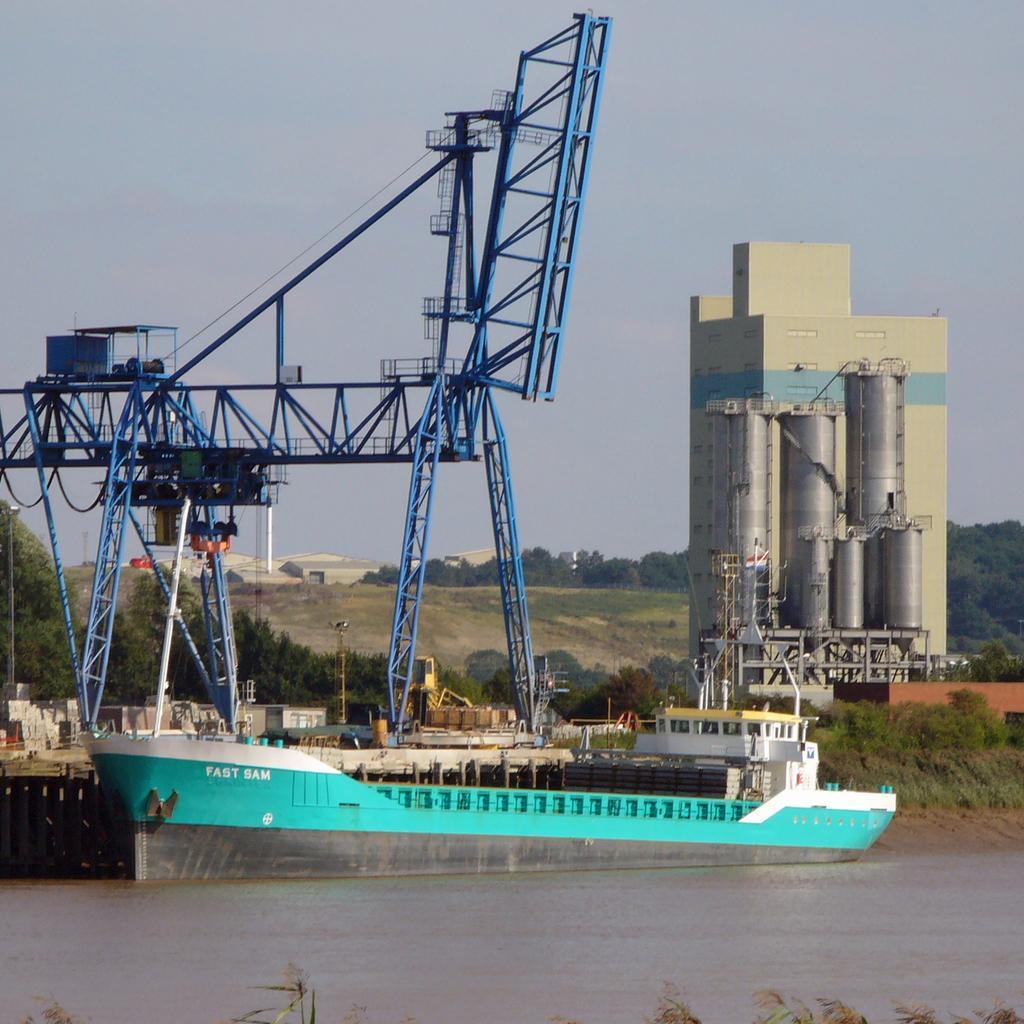In one or two sentences, can you explain what this image depicts? In this image at the bottom there is a river and in the river there is a ship, in the ship there are some poles and in the background there are some towers, trees, mountains and buildings and also we can see some poles and objects. And at the top of the image there is sky. 